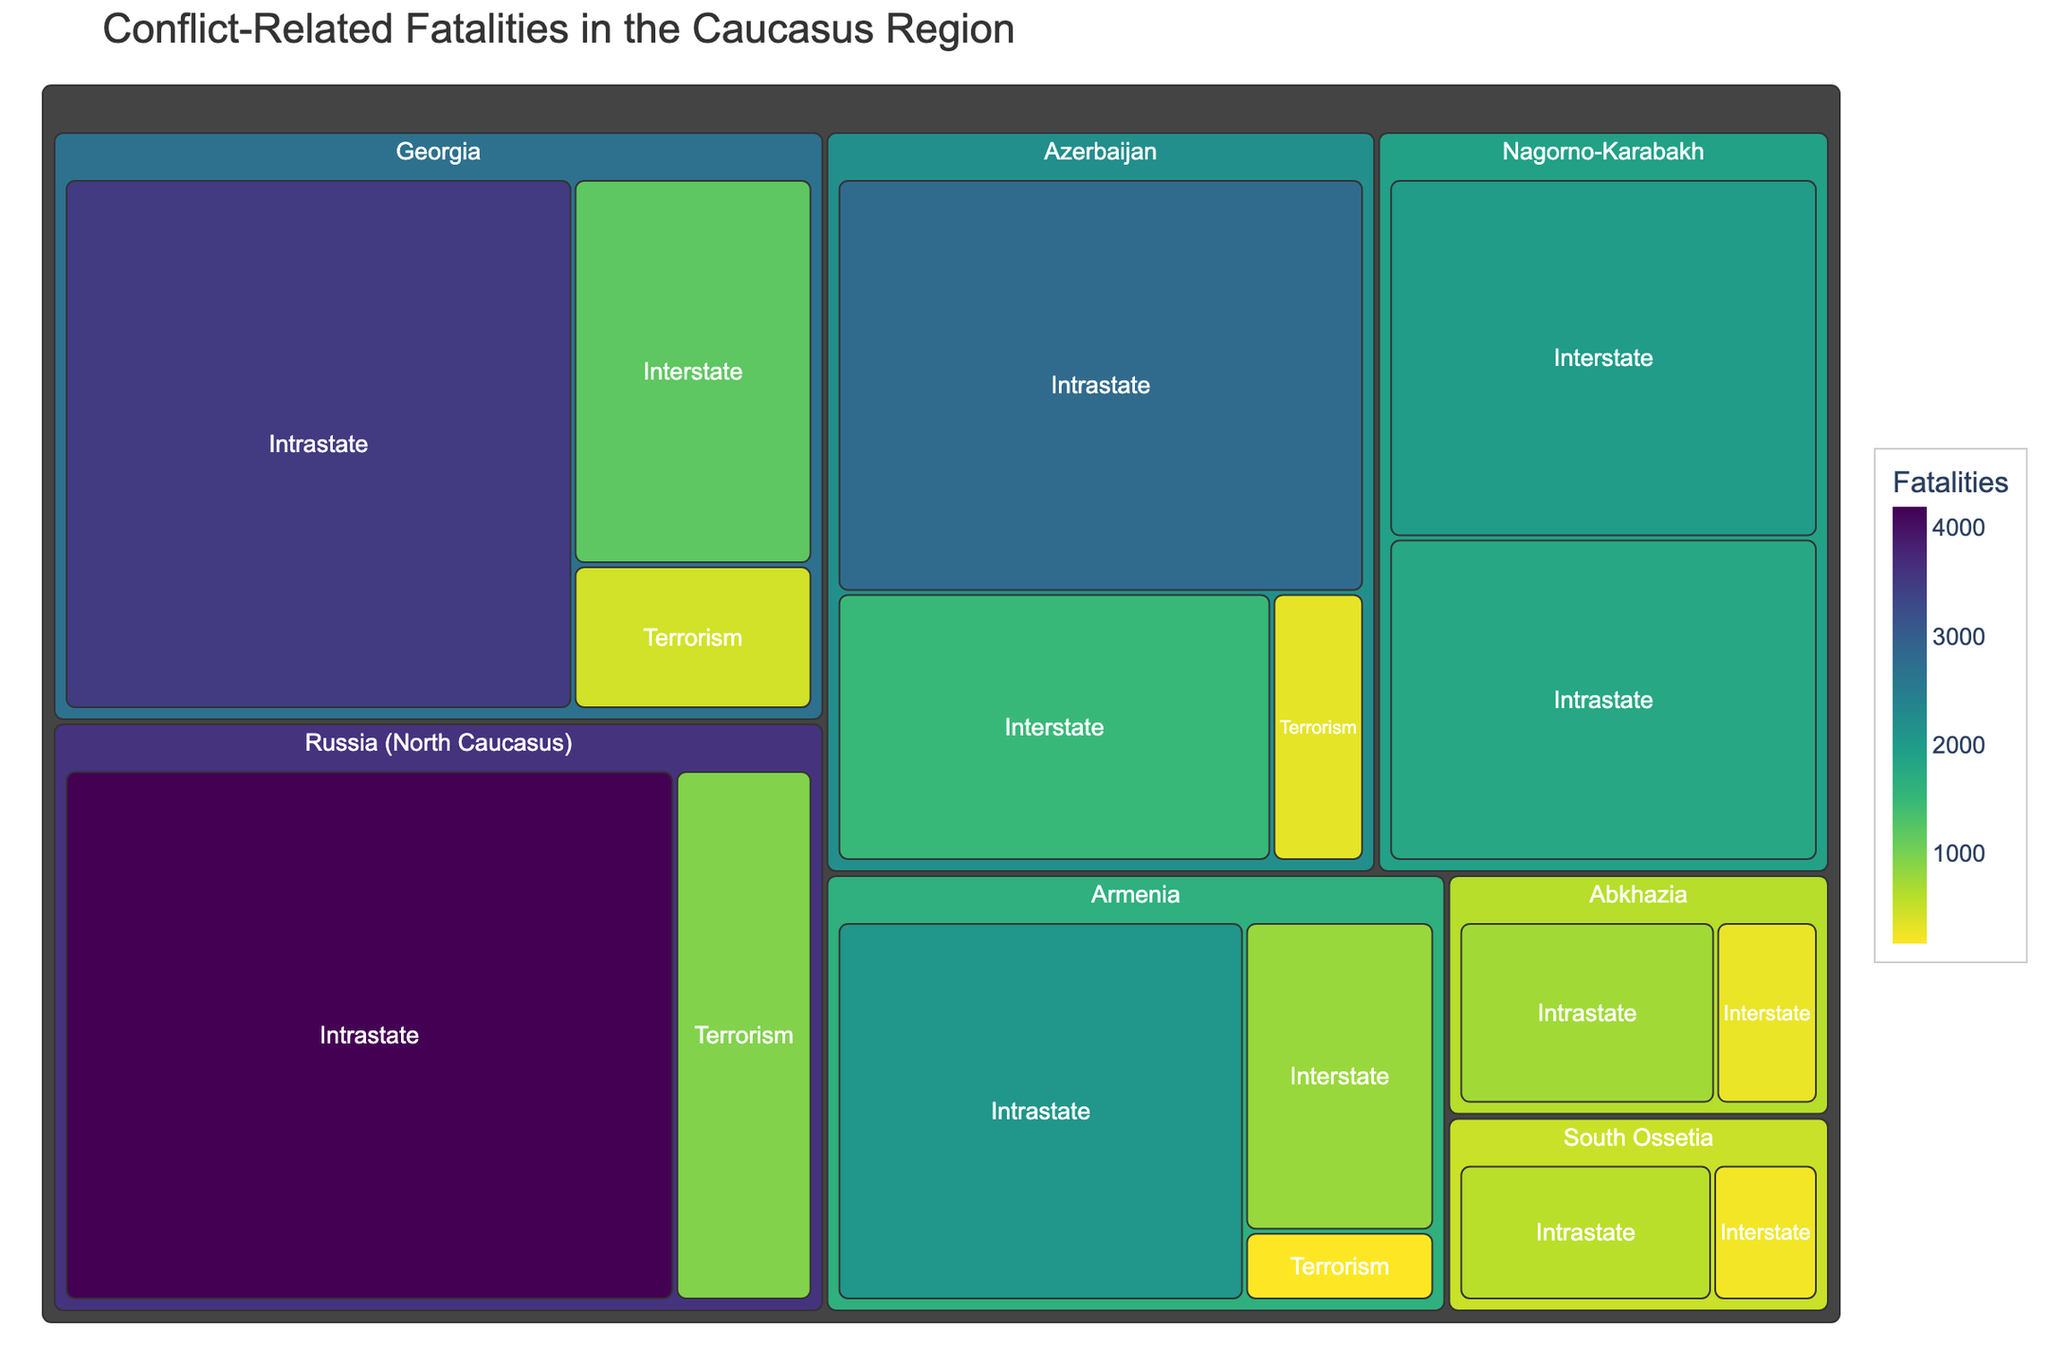What's the title of the treemap? The title is usually displayed prominently at the top of the treemap. By reading the top part of the figure, you can easily identify the title.
Answer: Conflict-Related Fatalities in the Caucasus Region Which country has the highest intrastate fatalities? To determine the country with the highest intrastate fatalities, look for the largest and darkest colored segment in the "Intrastate" category. Compare these segments across different countries.
Answer: Russia (North Caucasus) How many fatalities are there in Georgia due to interstate conflict? Identify the section of the treemap labeled "Georgia" and then look specifically at the sub-section for "Interstate". The number of fatalities can be read directly from this part of the figure.
Answer: 1200 Compare the number of interstate fatalities in Armenia and Azerbaijan. Which country has more, and by how much? Compare the "Interstate" segments within Armenia and Azerbaijan. Subtract the smaller value from the larger one to find the difference. Armenia has 800 fatalities and Azerbaijan has 1500.
Answer: Azerbaijan, by 700 What is the total number of fatalities in South Ossetia from all types of conflict? Sum the numbers of fatalities from each conflict type under South Ossetia. South Ossetia has 250 (Interstate) + 600 (Intrastate).
Answer: 850 Which conflict type has the most fatalities in the entire dataset? Look for the conflict type with the largest combined size across all countries. Compare the total size of each type of conflict.
Answer: Intrastate Compare the fatalities in Nagorno-Karabakh due to interstate conflict with those due to intrastate conflict. What is the difference? Identify both segments for Nagorno-Karabakh. Subtract the number of intrastate fatalities from the number of interstate fatalities. Nagorno-Karabakh has 2000 (Interstate) - 1800 (Intrastate).
Answer: 200 Which three countries/regions have the highest number of terrorism-related fatalities? Identify the segments under "Terrorism" for each country/region. Compare their sizes and fatalities numbers, listing the top three.
Answer: Russia (North Caucasus), Georgia, Azerbaijan What is the average number of terrorism-related fatalities across all countries? Add the numbers of terrorism-related fatalities from all countries then divide by the number of countries/regions with terrorism data: (450+180+320+950)/4=1900/4.
Answer: 475 Which conflict type is least prevalent in Abkhazia? Compare the fatality numbers within Abkhazia for each conflict type (Interstate and Intrastate) and identify the smallest value.
Answer: Interstate 